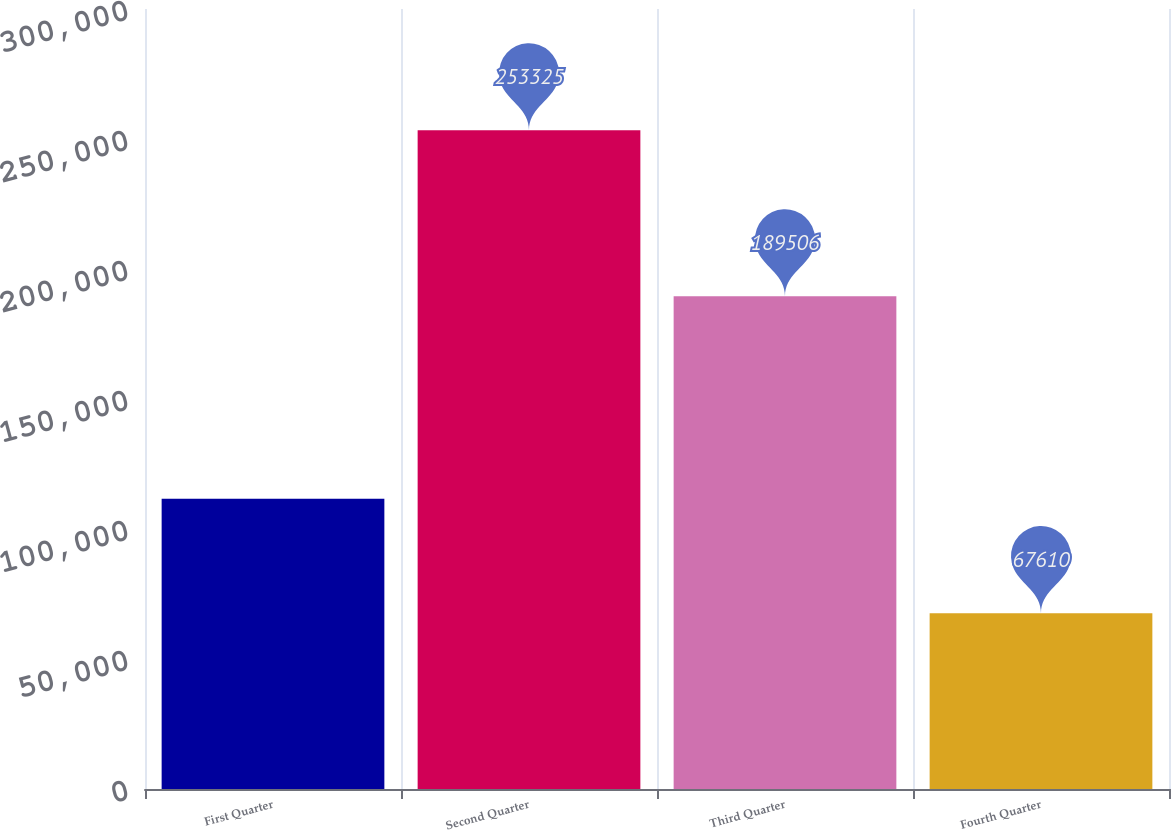<chart> <loc_0><loc_0><loc_500><loc_500><bar_chart><fcel>First Quarter<fcel>Second Quarter<fcel>Third Quarter<fcel>Fourth Quarter<nl><fcel>111606<fcel>253325<fcel>189506<fcel>67610<nl></chart> 